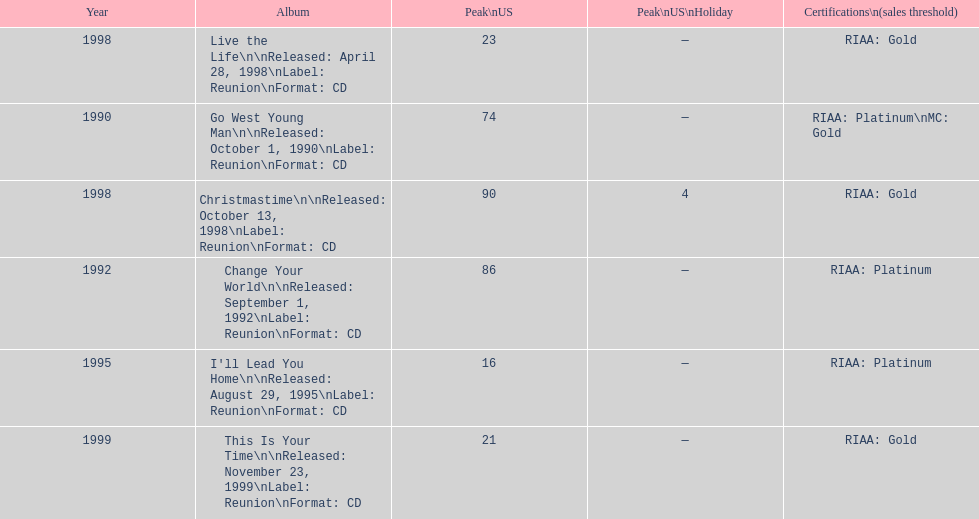Which michael w smith album had the highest ranking on the us chart? I'll Lead You Home. 